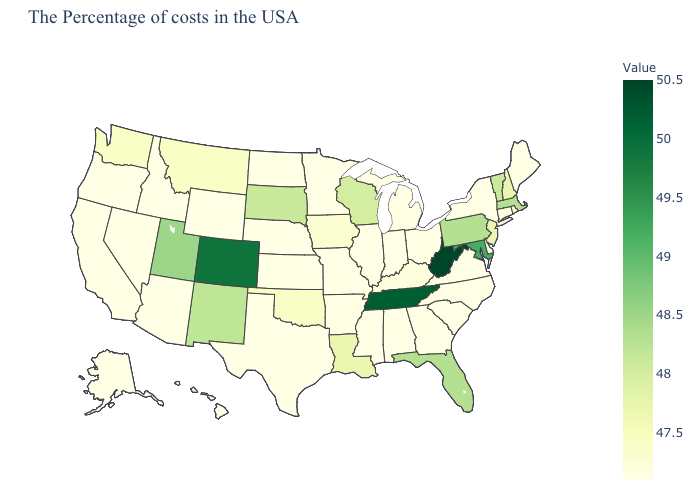Does California have a higher value than Utah?
Give a very brief answer. No. Among the states that border Mississippi , does Tennessee have the highest value?
Be succinct. Yes. Which states hav the highest value in the MidWest?
Be succinct. South Dakota. Does Washington have the lowest value in the West?
Short answer required. No. Does West Virginia have the highest value in the USA?
Keep it brief. Yes. Does Oklahoma have the lowest value in the South?
Concise answer only. No. Among the states that border Nebraska , which have the highest value?
Be succinct. Colorado. Among the states that border Louisiana , which have the lowest value?
Concise answer only. Mississippi, Arkansas, Texas. Does North Carolina have a higher value than South Dakota?
Keep it brief. No. 